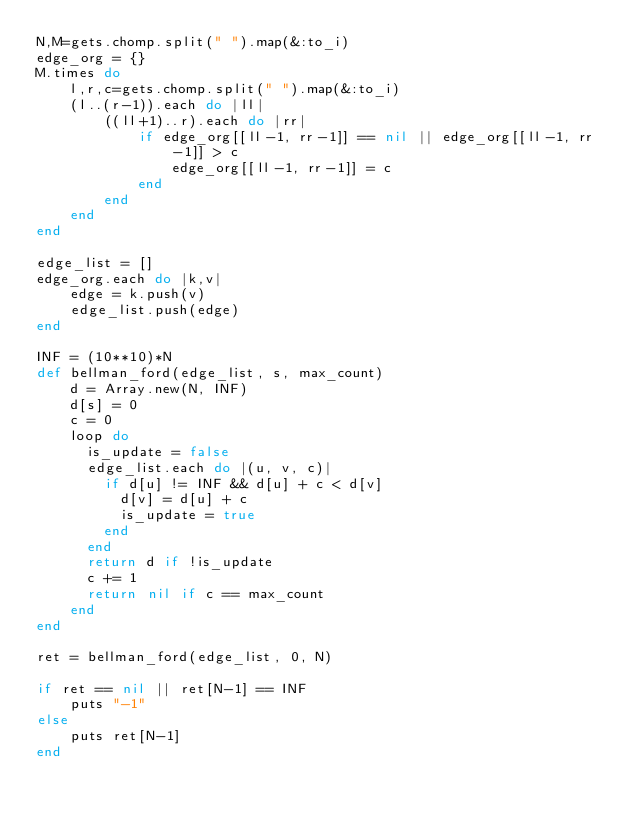<code> <loc_0><loc_0><loc_500><loc_500><_Ruby_>N,M=gets.chomp.split(" ").map(&:to_i)
edge_org = {}
M.times do
    l,r,c=gets.chomp.split(" ").map(&:to_i)
    (l..(r-1)).each do |ll|
        ((ll+1)..r).each do |rr|
            if edge_org[[ll-1, rr-1]] == nil || edge_org[[ll-1, rr-1]] > c
                edge_org[[ll-1, rr-1]] = c
            end
        end
    end
end

edge_list = []
edge_org.each do |k,v|
    edge = k.push(v)
    edge_list.push(edge)
end

INF = (10**10)*N
def bellman_ford(edge_list, s, max_count)
    d = Array.new(N, INF)
    d[s] = 0
    c = 0
    loop do
      is_update = false
      edge_list.each do |(u, v, c)|
        if d[u] != INF && d[u] + c < d[v]
          d[v] = d[u] + c
          is_update = true
        end
      end
      return d if !is_update
      c += 1
      return nil if c == max_count
    end
end

ret = bellman_ford(edge_list, 0, N)

if ret == nil || ret[N-1] == INF
    puts "-1"
else
    puts ret[N-1]
end</code> 